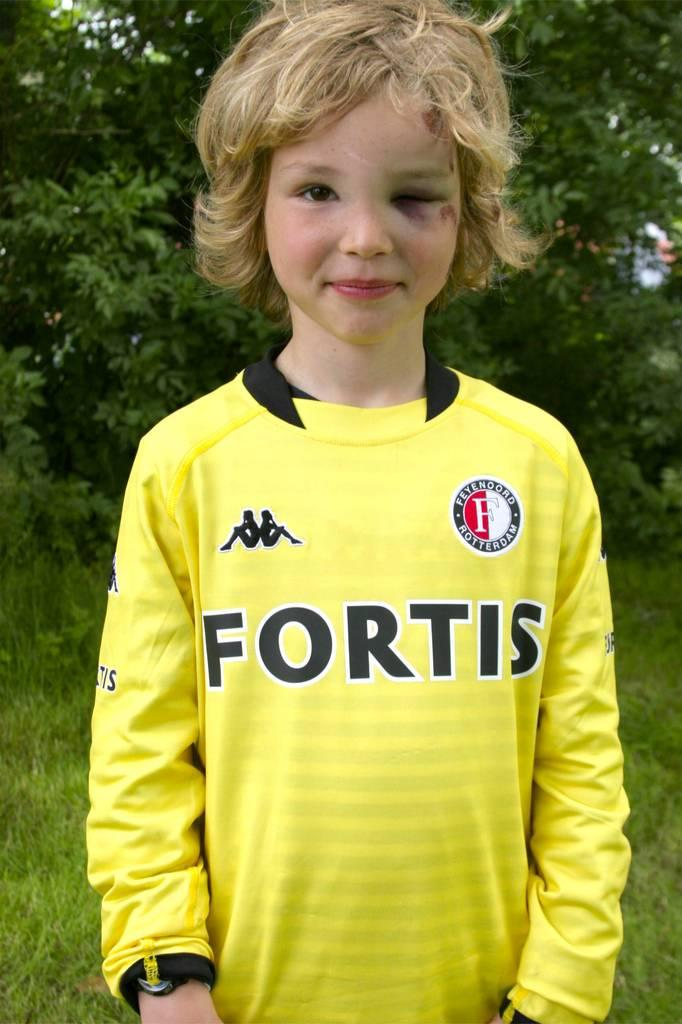<image>
Relay a brief, clear account of the picture shown. a boy with a yellow t-shirt from fortis team 